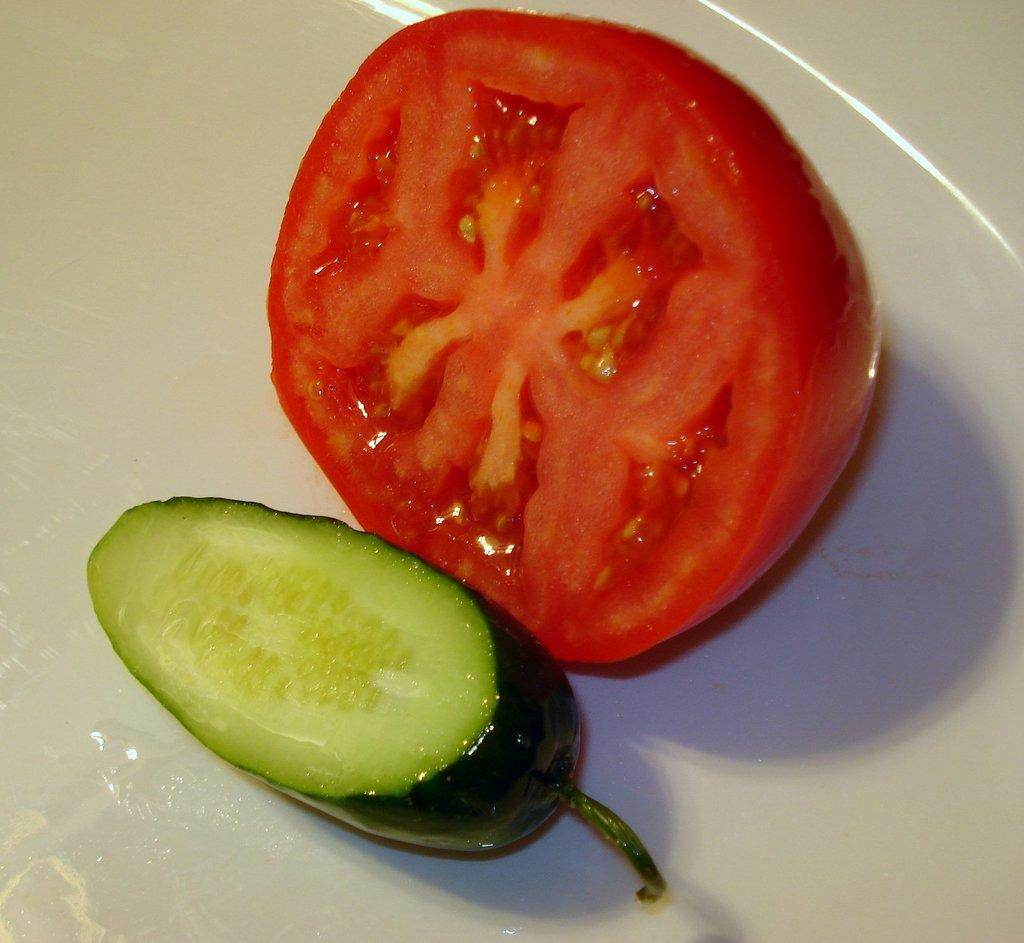What is present on the plate in the image? There are two types of vegetables on a plate in the image. Can you describe the vegetables on the plate? Unfortunately, the specific types of vegetables cannot be determined from the provided facts. What might be a common way to serve or consume these vegetables? The vegetables on the plate might be served as a side dish or part of a meal. How many women are climbing the tree in the image? There is no tree or women present in the image; it features a plate with two types of vegetables. How many pigs are visible in the image? There are no pigs present in the image; it features a plate with two types of vegetables. 